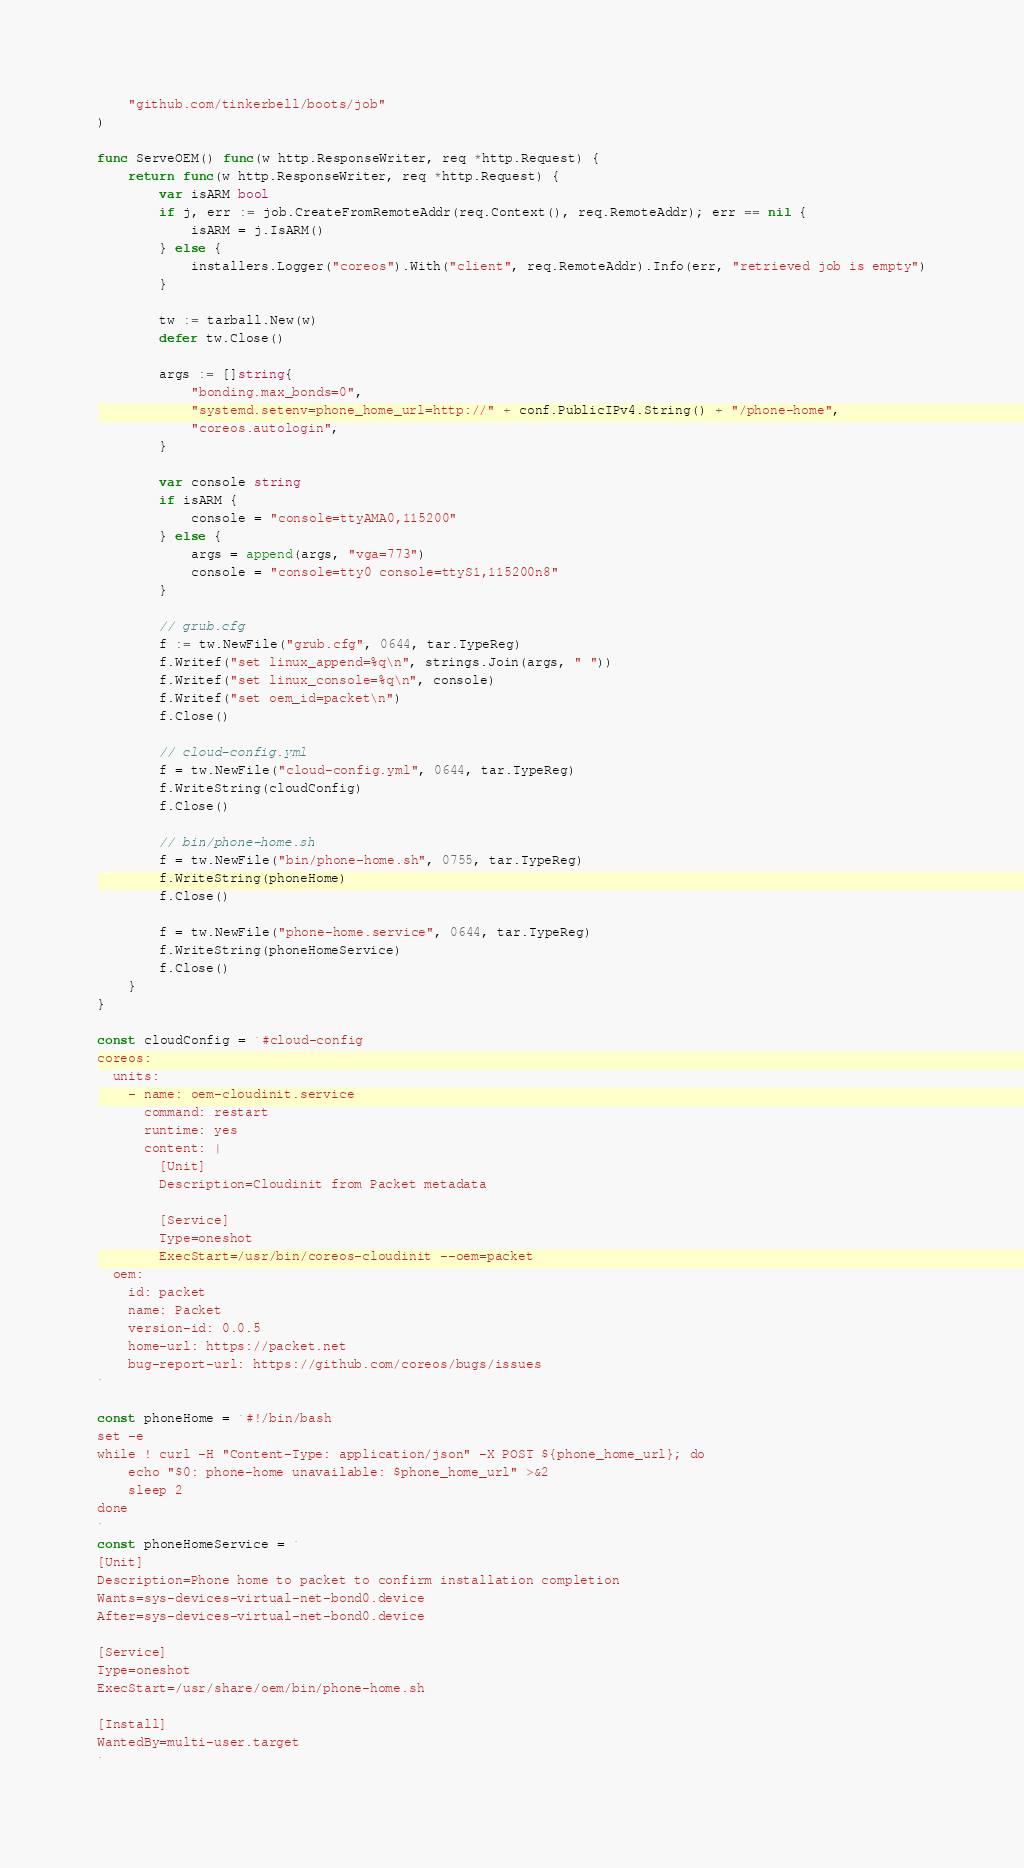<code> <loc_0><loc_0><loc_500><loc_500><_Go_>	"github.com/tinkerbell/boots/job"
)

func ServeOEM() func(w http.ResponseWriter, req *http.Request) {
	return func(w http.ResponseWriter, req *http.Request) {
		var isARM bool
		if j, err := job.CreateFromRemoteAddr(req.Context(), req.RemoteAddr); err == nil {
			isARM = j.IsARM()
		} else {
			installers.Logger("coreos").With("client", req.RemoteAddr).Info(err, "retrieved job is empty")
		}

		tw := tarball.New(w)
		defer tw.Close()

		args := []string{
			"bonding.max_bonds=0",
			"systemd.setenv=phone_home_url=http://" + conf.PublicIPv4.String() + "/phone-home",
			"coreos.autologin",
		}

		var console string
		if isARM {
			console = "console=ttyAMA0,115200"
		} else {
			args = append(args, "vga=773")
			console = "console=tty0 console=ttyS1,115200n8"
		}

		// grub.cfg
		f := tw.NewFile("grub.cfg", 0644, tar.TypeReg)
		f.Writef("set linux_append=%q\n", strings.Join(args, " "))
		f.Writef("set linux_console=%q\n", console)
		f.Writef("set oem_id=packet\n")
		f.Close()

		// cloud-config.yml
		f = tw.NewFile("cloud-config.yml", 0644, tar.TypeReg)
		f.WriteString(cloudConfig)
		f.Close()

		// bin/phone-home.sh
		f = tw.NewFile("bin/phone-home.sh", 0755, tar.TypeReg)
		f.WriteString(phoneHome)
		f.Close()

		f = tw.NewFile("phone-home.service", 0644, tar.TypeReg)
		f.WriteString(phoneHomeService)
		f.Close()
	}
}

const cloudConfig = `#cloud-config
coreos:
  units:
    - name: oem-cloudinit.service
      command: restart
      runtime: yes
      content: |
        [Unit]
        Description=Cloudinit from Packet metadata

        [Service]
        Type=oneshot
        ExecStart=/usr/bin/coreos-cloudinit --oem=packet
  oem:
    id: packet
    name: Packet
    version-id: 0.0.5
    home-url: https://packet.net
    bug-report-url: https://github.com/coreos/bugs/issues
`

const phoneHome = `#!/bin/bash
set -e
while ! curl -H "Content-Type: application/json" -X POST ${phone_home_url}; do
	echo "$0: phone-home unavailable: $phone_home_url" >&2
	sleep 2
done
`
const phoneHomeService = `
[Unit]
Description=Phone home to packet to confirm installation completion
Wants=sys-devices-virtual-net-bond0.device
After=sys-devices-virtual-net-bond0.device

[Service]
Type=oneshot
ExecStart=/usr/share/oem/bin/phone-home.sh

[Install]
WantedBy=multi-user.target
`
</code> 